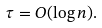Convert formula to latex. <formula><loc_0><loc_0><loc_500><loc_500>\tau = O ( \log n ) .</formula> 